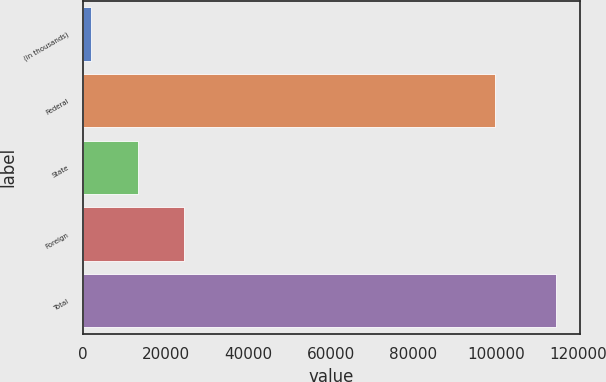Convert chart. <chart><loc_0><loc_0><loc_500><loc_500><bar_chart><fcel>(in thousands)<fcel>Federal<fcel>State<fcel>Foreign<fcel>Total<nl><fcel>2016<fcel>99783<fcel>13282.3<fcel>24548.6<fcel>114679<nl></chart> 